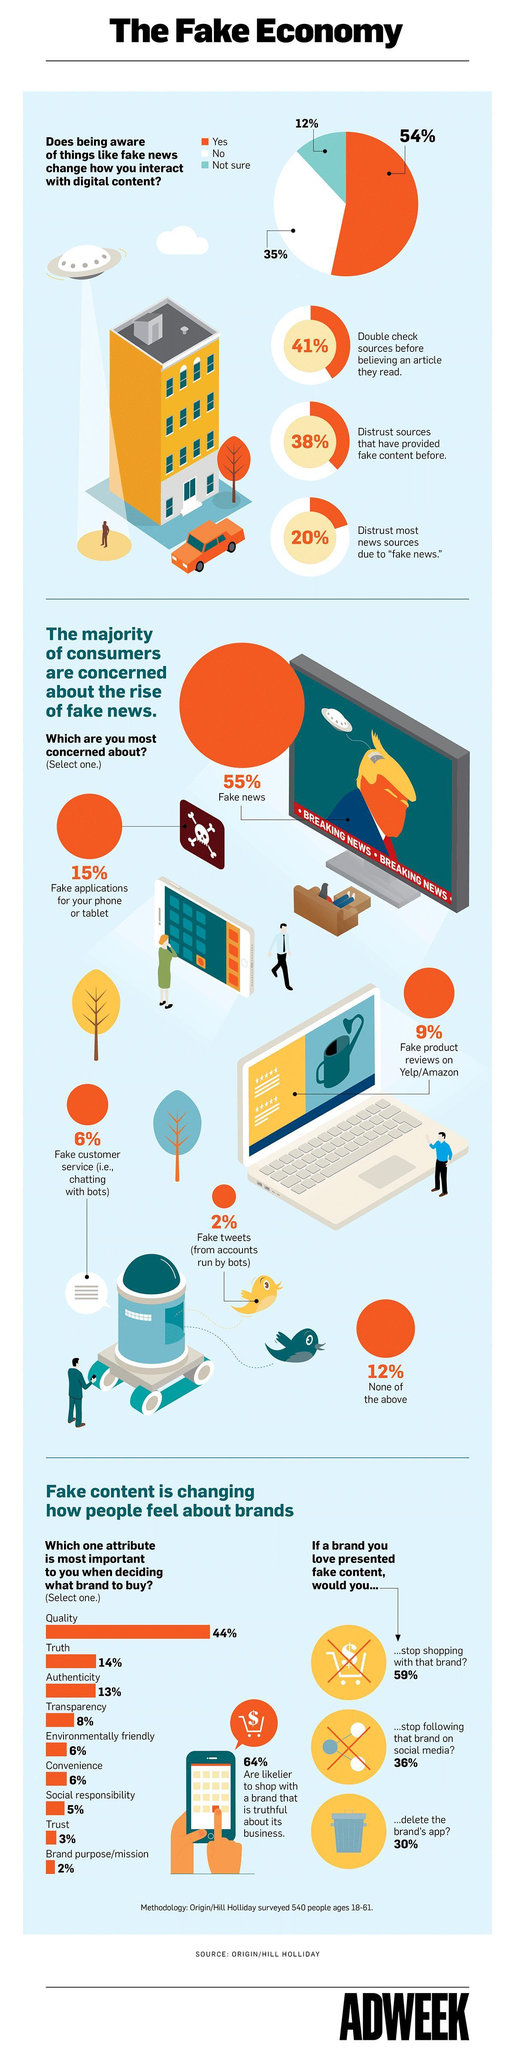What percentage of people are not double-checking sources before believing an article they read?
Answer the question with a short phrase. 59% What percentage of truth and trust do people consider when deciding what brand to buy? 17% What percentage of authenticity and quality do people consider when deciding what brand to buy? 57% What percentage of tweets are not fake? 98% What percentage of customer service are not fake? 94% What percentage of applications for phones/tablets are not fake? 85% What percentage of people trust sources that have provided fake content before? 62% What percentage of reviews on amazon about the product are not fake? 91% What percentage of convenience and transparency do people consider when deciding what brand to buy? 14% What percentage of news are not fake? 45% 